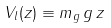<formula> <loc_0><loc_0><loc_500><loc_500>V _ { l } ( z ) \equiv m _ { g } \, g \, z</formula> 